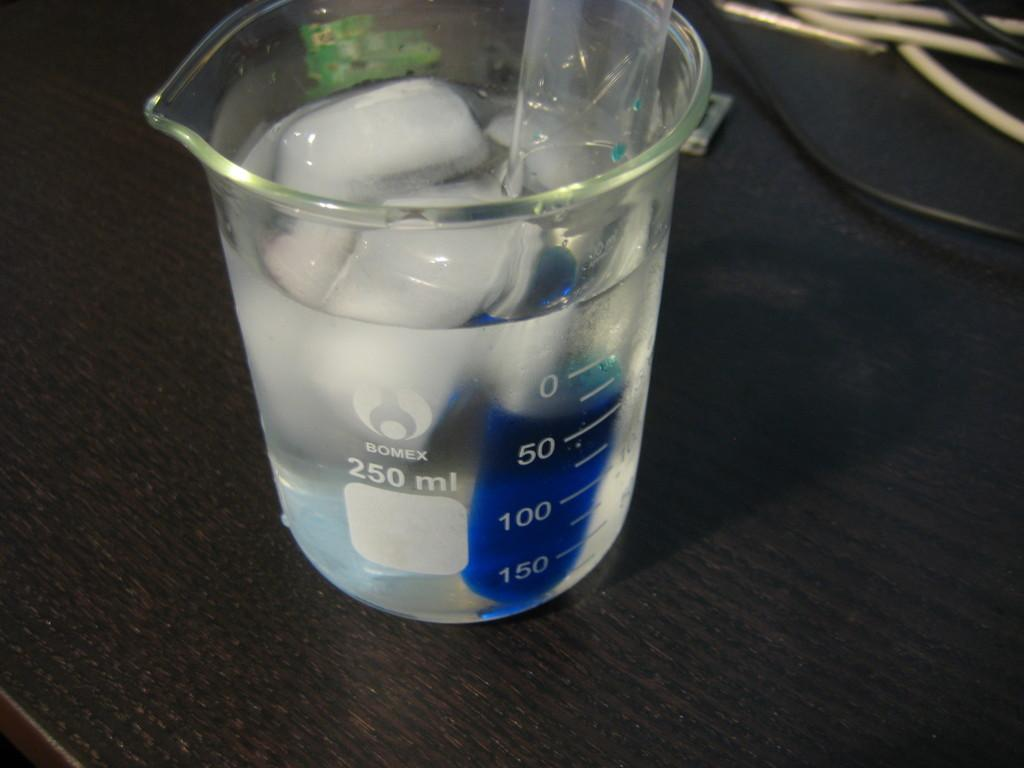Provide a one-sentence caption for the provided image. A 250 ml beaker is filed with liquid and ice cubes. 